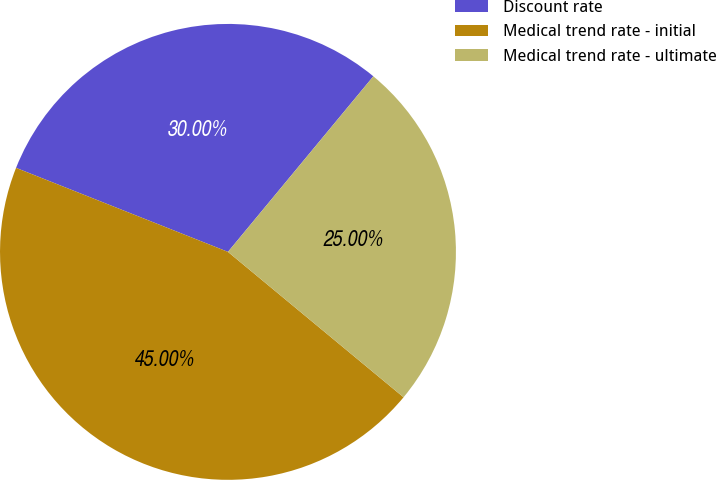<chart> <loc_0><loc_0><loc_500><loc_500><pie_chart><fcel>Discount rate<fcel>Medical trend rate - initial<fcel>Medical trend rate - ultimate<nl><fcel>30.0%<fcel>45.0%<fcel>25.0%<nl></chart> 